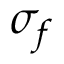<formula> <loc_0><loc_0><loc_500><loc_500>\sigma _ { f }</formula> 